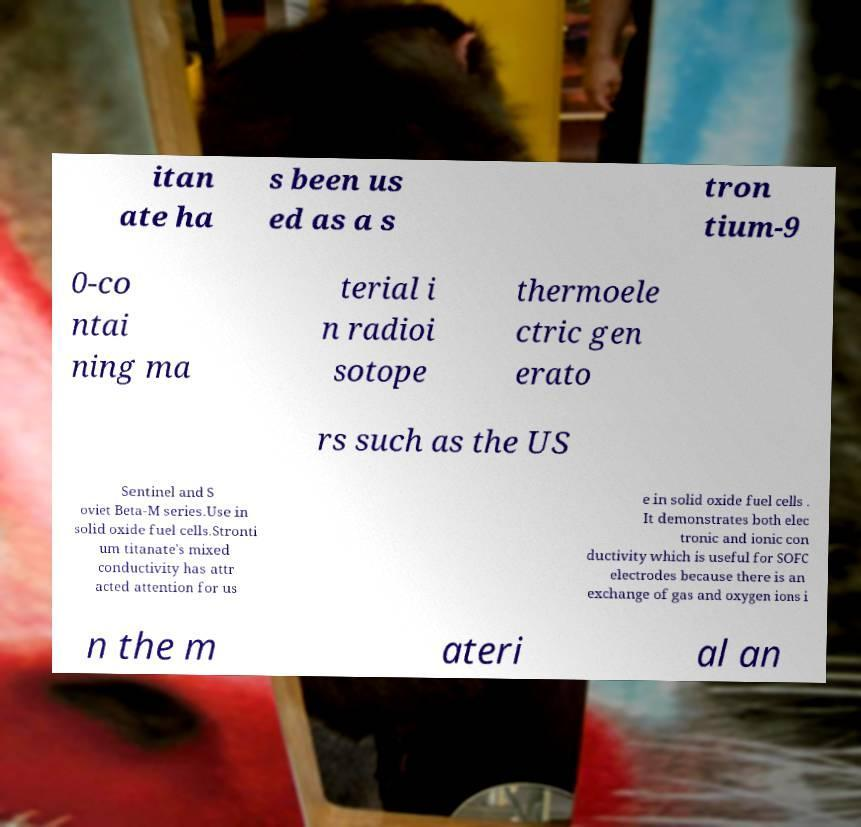Could you assist in decoding the text presented in this image and type it out clearly? itan ate ha s been us ed as a s tron tium-9 0-co ntai ning ma terial i n radioi sotope thermoele ctric gen erato rs such as the US Sentinel and S oviet Beta-M series.Use in solid oxide fuel cells.Stronti um titanate's mixed conductivity has attr acted attention for us e in solid oxide fuel cells . It demonstrates both elec tronic and ionic con ductivity which is useful for SOFC electrodes because there is an exchange of gas and oxygen ions i n the m ateri al an 